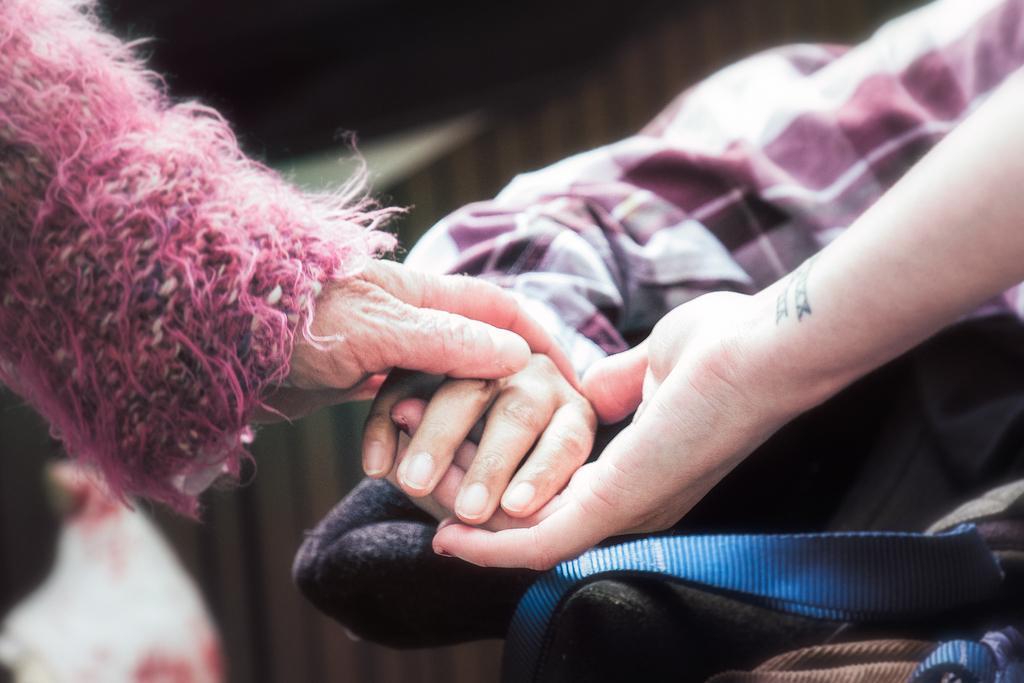How would you summarize this image in a sentence or two? In this image we can see some helping hands hold together. 